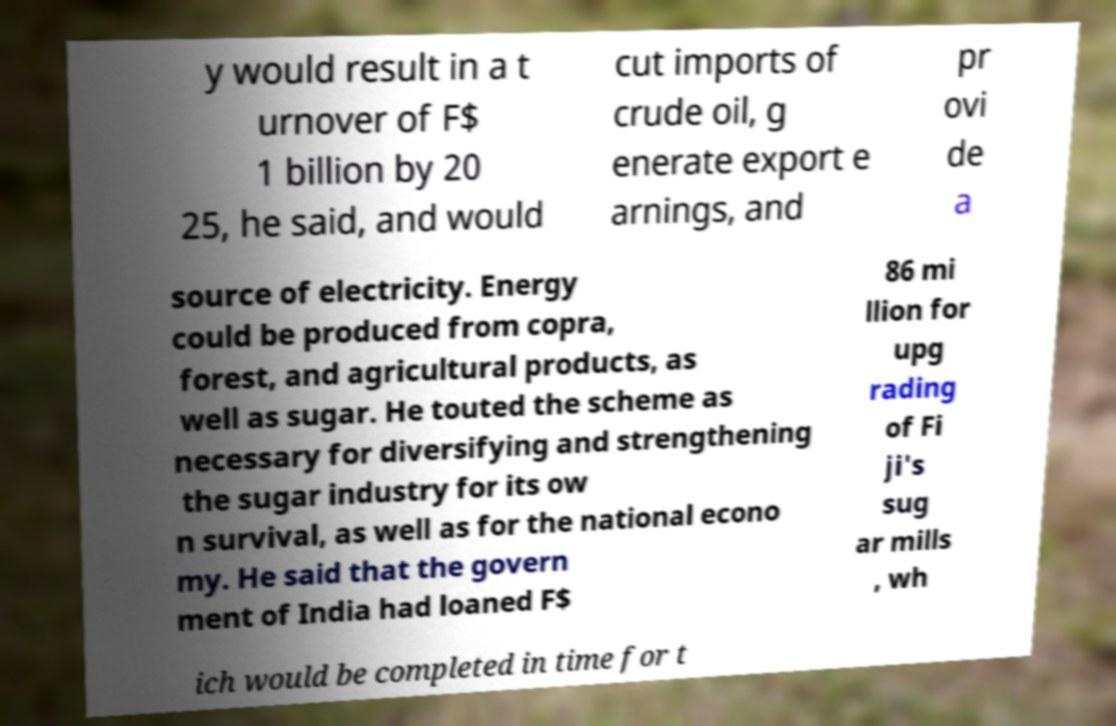Could you extract and type out the text from this image? y would result in a t urnover of F$ 1 billion by 20 25, he said, and would cut imports of crude oil, g enerate export e arnings, and pr ovi de a source of electricity. Energy could be produced from copra, forest, and agricultural products, as well as sugar. He touted the scheme as necessary for diversifying and strengthening the sugar industry for its ow n survival, as well as for the national econo my. He said that the govern ment of India had loaned F$ 86 mi llion for upg rading of Fi ji's sug ar mills , wh ich would be completed in time for t 